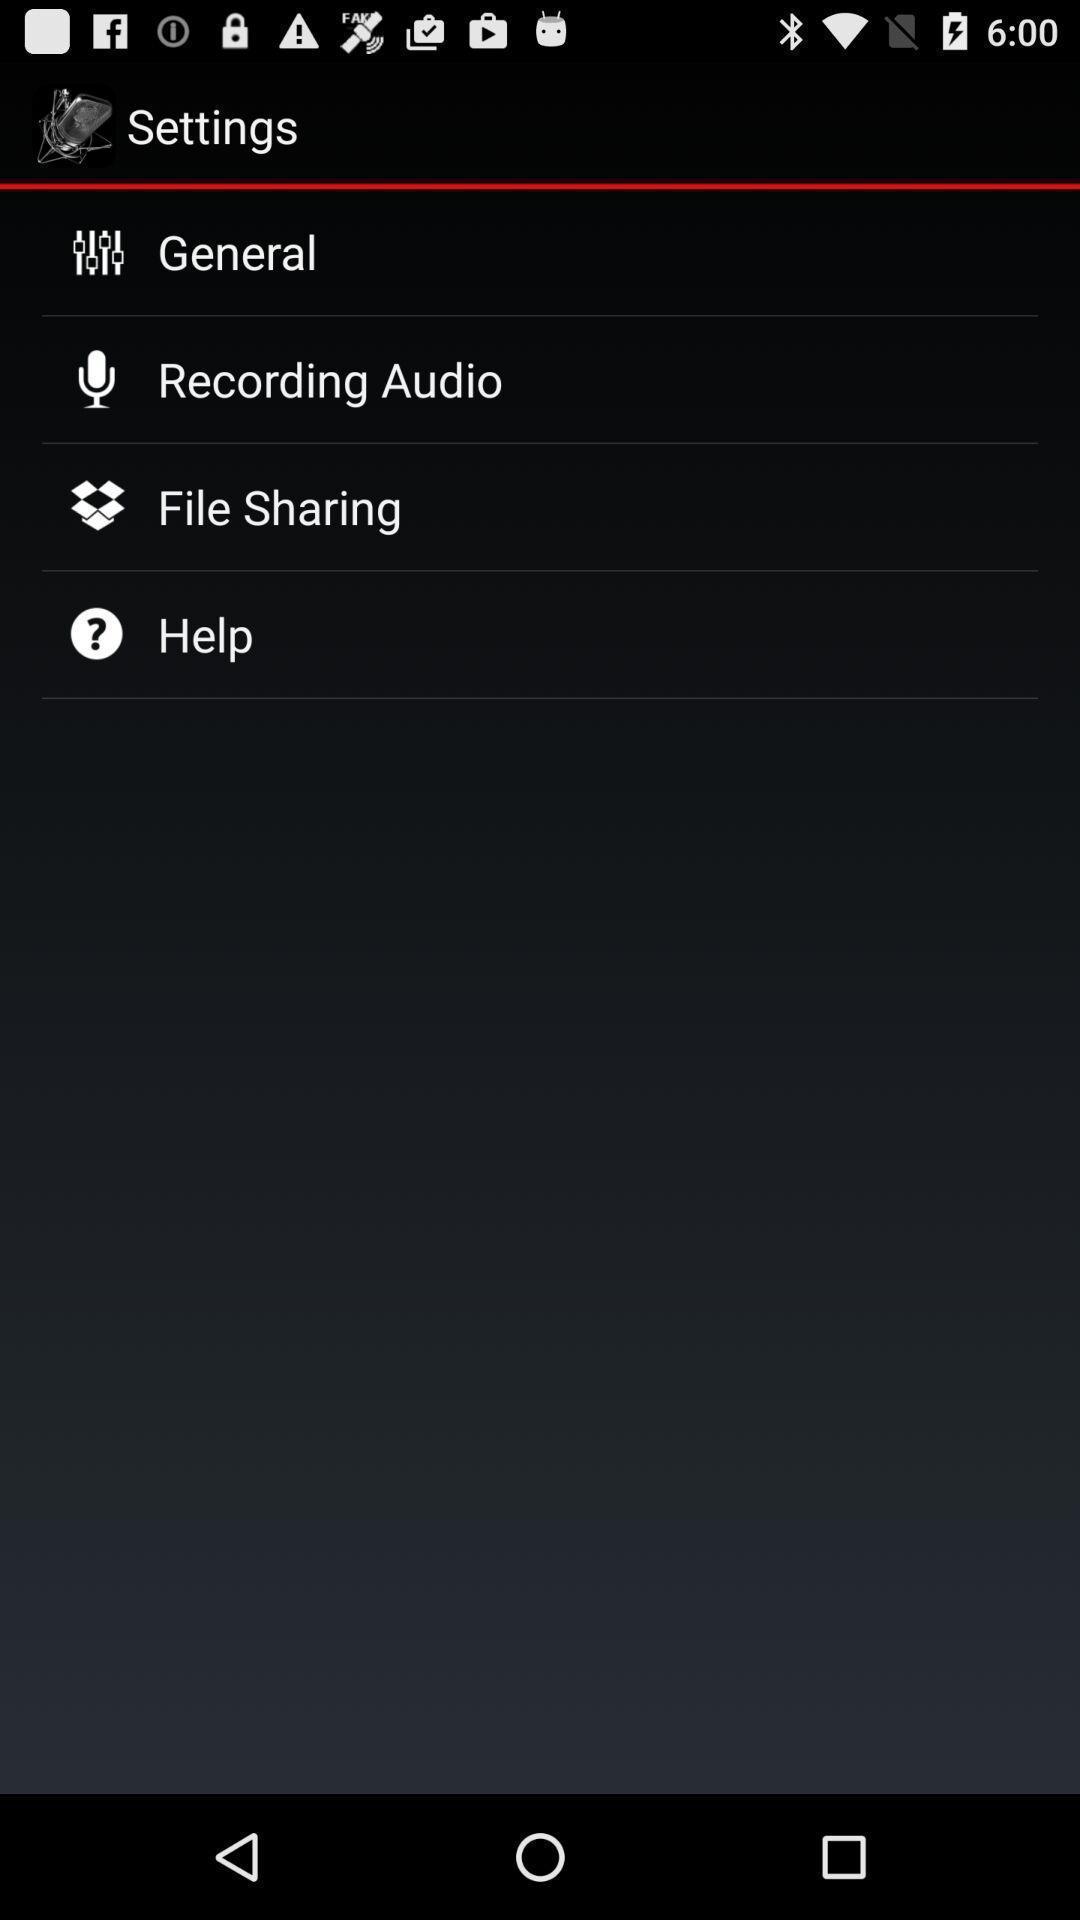Give me a narrative description of this picture. Settings page. 